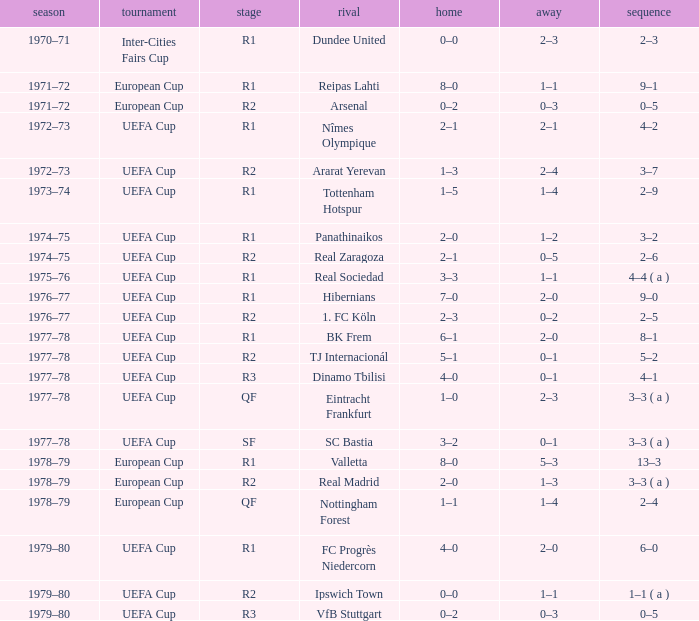Which Season has an Opponent of hibernians? 1976–77. 